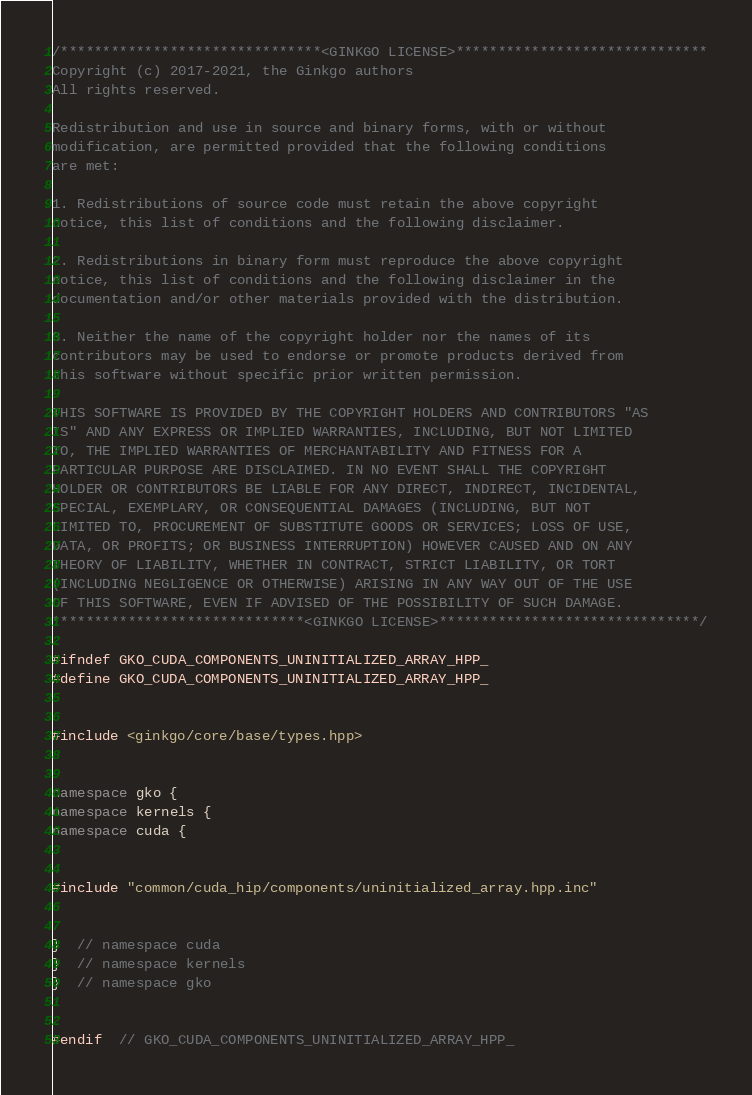<code> <loc_0><loc_0><loc_500><loc_500><_C++_>/*******************************<GINKGO LICENSE>******************************
Copyright (c) 2017-2021, the Ginkgo authors
All rights reserved.

Redistribution and use in source and binary forms, with or without
modification, are permitted provided that the following conditions
are met:

1. Redistributions of source code must retain the above copyright
notice, this list of conditions and the following disclaimer.

2. Redistributions in binary form must reproduce the above copyright
notice, this list of conditions and the following disclaimer in the
documentation and/or other materials provided with the distribution.

3. Neither the name of the copyright holder nor the names of its
contributors may be used to endorse or promote products derived from
this software without specific prior written permission.

THIS SOFTWARE IS PROVIDED BY THE COPYRIGHT HOLDERS AND CONTRIBUTORS "AS
IS" AND ANY EXPRESS OR IMPLIED WARRANTIES, INCLUDING, BUT NOT LIMITED
TO, THE IMPLIED WARRANTIES OF MERCHANTABILITY AND FITNESS FOR A
PARTICULAR PURPOSE ARE DISCLAIMED. IN NO EVENT SHALL THE COPYRIGHT
HOLDER OR CONTRIBUTORS BE LIABLE FOR ANY DIRECT, INDIRECT, INCIDENTAL,
SPECIAL, EXEMPLARY, OR CONSEQUENTIAL DAMAGES (INCLUDING, BUT NOT
LIMITED TO, PROCUREMENT OF SUBSTITUTE GOODS OR SERVICES; LOSS OF USE,
DATA, OR PROFITS; OR BUSINESS INTERRUPTION) HOWEVER CAUSED AND ON ANY
THEORY OF LIABILITY, WHETHER IN CONTRACT, STRICT LIABILITY, OR TORT
(INCLUDING NEGLIGENCE OR OTHERWISE) ARISING IN ANY WAY OUT OF THE USE
OF THIS SOFTWARE, EVEN IF ADVISED OF THE POSSIBILITY OF SUCH DAMAGE.
******************************<GINKGO LICENSE>*******************************/

#ifndef GKO_CUDA_COMPONENTS_UNINITIALIZED_ARRAY_HPP_
#define GKO_CUDA_COMPONENTS_UNINITIALIZED_ARRAY_HPP_


#include <ginkgo/core/base/types.hpp>


namespace gko {
namespace kernels {
namespace cuda {


#include "common/cuda_hip/components/uninitialized_array.hpp.inc"


}  // namespace cuda
}  // namespace kernels
}  // namespace gko


#endif  // GKO_CUDA_COMPONENTS_UNINITIALIZED_ARRAY_HPP_
</code> 